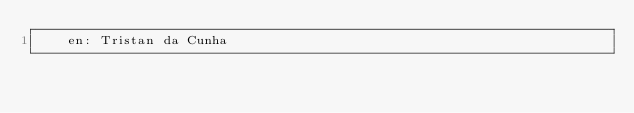<code> <loc_0><loc_0><loc_500><loc_500><_YAML_>    en: Tristan da Cunha
</code> 